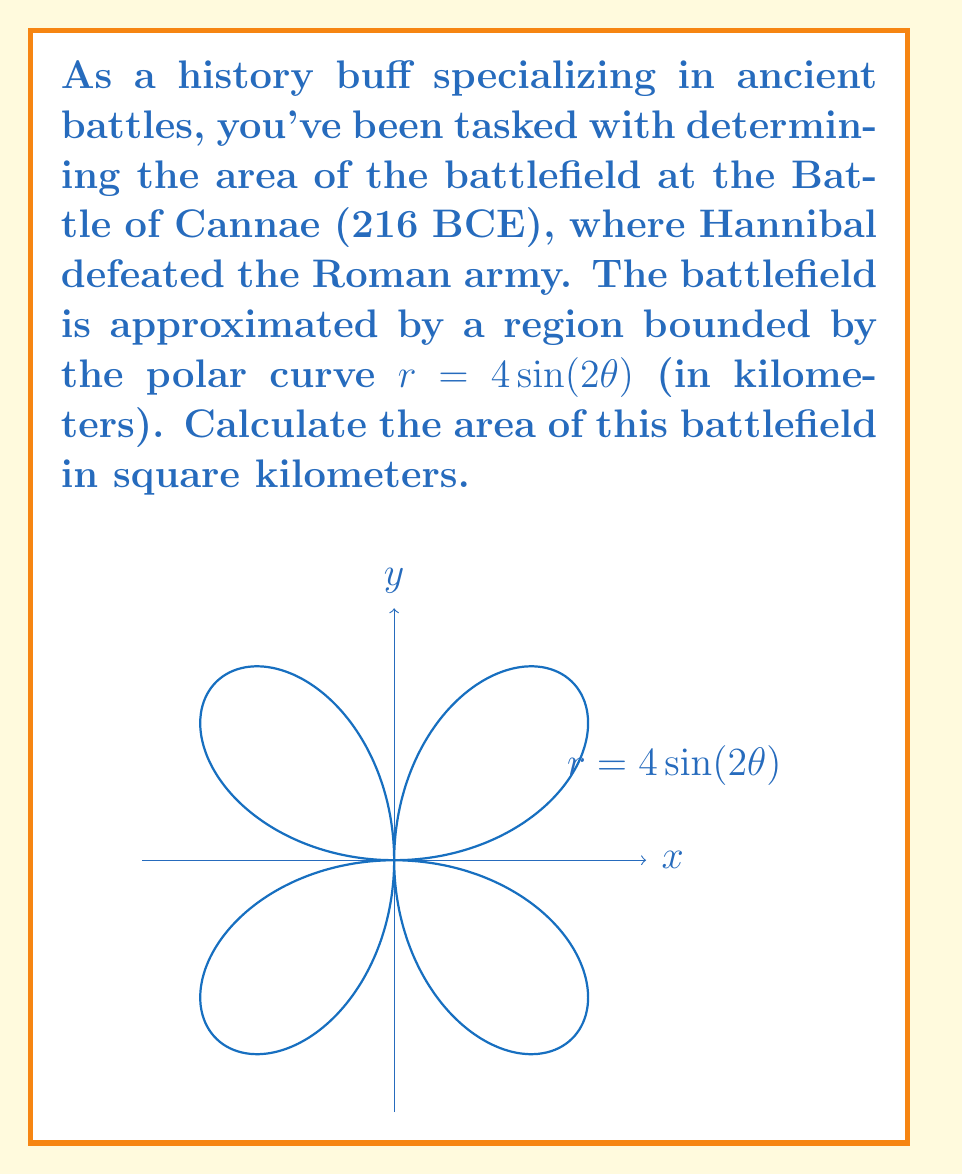Can you answer this question? Let's approach this step-by-step:

1) The area of a region bounded by a polar curve is given by the formula:

   $$A = \frac{1}{2} \int_{0}^{2\pi} r^2 d\theta$$

2) In this case, $r = 4\sin(2\theta)$. We need to square this:

   $$r^2 = 16\sin^2(2\theta)$$

3) Substituting this into our area formula:

   $$A = \frac{1}{2} \int_{0}^{2\pi} 16\sin^2(2\theta) d\theta$$

4) We can simplify this to:

   $$A = 8 \int_{0}^{2\pi} \sin^2(2\theta) d\theta$$

5) We can use the trigonometric identity $\sin^2(x) = \frac{1 - \cos(2x)}{2}$:

   $$A = 8 \int_{0}^{2\pi} \frac{1 - \cos(4\theta)}{2} d\theta$$

6) Simplifying:

   $$A = 4 \int_{0}^{2\pi} (1 - \cos(4\theta)) d\theta$$

7) Integrating:

   $$A = 4 \left[\theta - \frac{1}{4}\sin(4\theta)\right]_{0}^{2\pi}$$

8) Evaluating the definite integral:

   $$A = 4 \left[(2\pi - 0) - (\frac{1}{4}\sin(8\pi) - \frac{1}{4}\sin(0))\right]$$

9) Simplifying:

   $$A = 4 \cdot 2\pi = 8\pi$$

Therefore, the area of the battlefield is $8\pi$ square kilometers.
Answer: $8\pi$ km² 